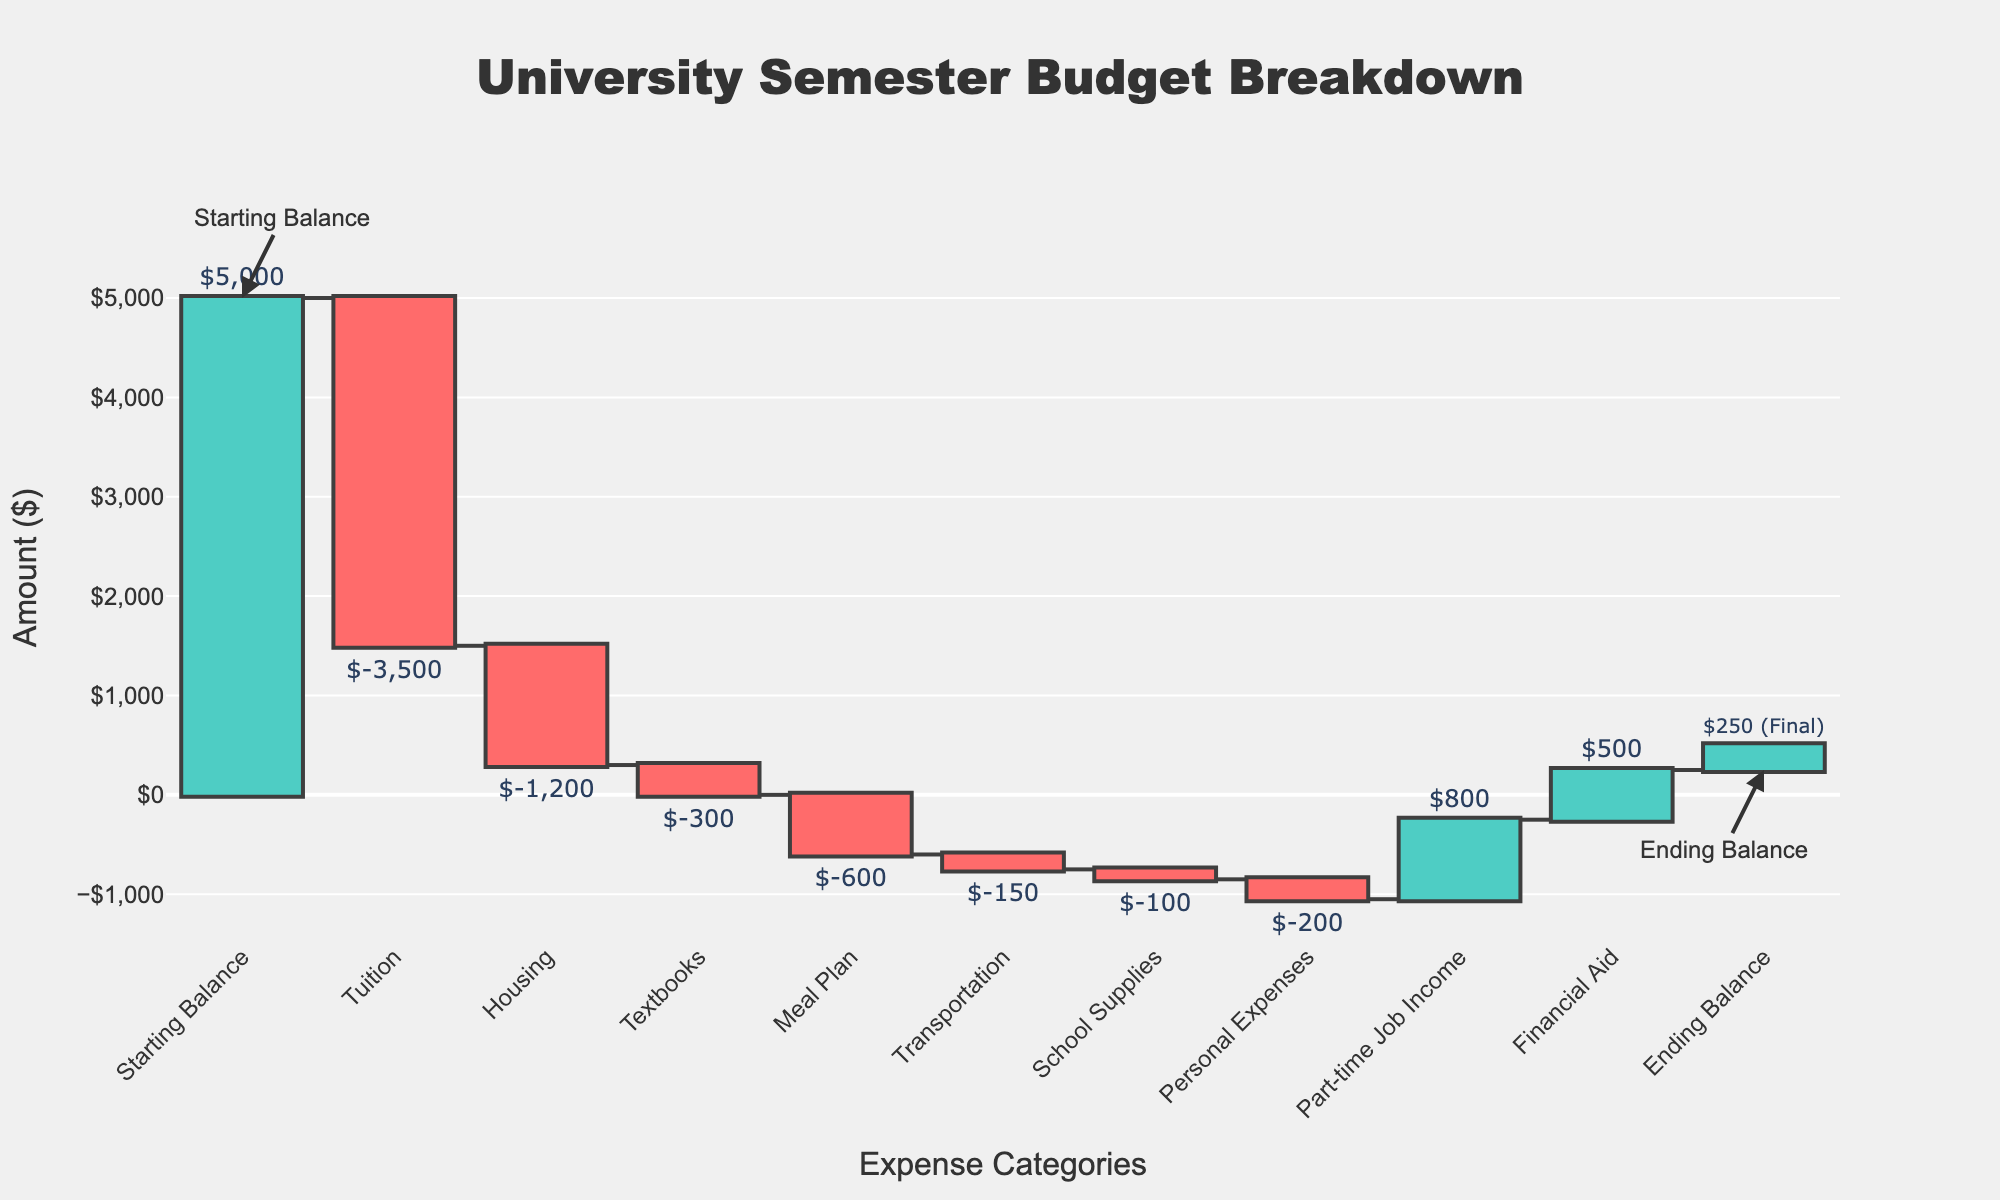What is the title of the Waterfall Chart? The title is displayed at the top of the figure and provides an overall description of the chart.
Answer: University Semester Budget Breakdown What is the starting balance? The starting balance is marked at the beginning of the Waterfall Chart and annotated as "Starting Balance."
Answer: $5,000 How does the tuition expense compare to the housing expense? The waterfall shows bars for both tuition and housing. The tuition expense bar is much larger, indicating it is the larger expense.
Answer: Tuition is higher What is the ending balance? The ending balance is annotated at the end of the chart and is marked as "Ending Balance."
Answer: $250 Which category has the largest negative impact on the budget? The longest negative bar on the chart indicates the largest expense, which corresponds to the category Tuition.
Answer: Tuition How much financial aid is received? The financial aid is represented by a positive bar labeled as Financial Aid.
Answer: $500 What is the net change in balance after including the part-time job income and financial aid? Start by identifying both positive bars for part-time job income ($800) and financial aid ($500). Add these two amounts together to find the net increase.
Answer: $1,300 What is the total amount spent on Textbooks, Meal Plan, and Personal Expenses? Identify the negative bars for Textbooks (-$300), Meal Plan (-$600), and Personal Expenses (-$200). Add these expenses together: -$300 + -$600 + -$200 = -$1,100.
Answer: $1,100 Which two categories together have a total expense of more than $3,000? Identify the expenses for each category. Tuition (-$3,500) alone already surpasses $3,000, so only tuition and any other expense (like Housing, -$1,200) would suffice. Tuition alone meets this.
Answer: Tuition alone What is the difference between the total amount spent on Housing and School Supplies? Identify the expenses: Housing (-$1,200) and School Supplies (-$100). Subtract the smaller from the larger: -$1,200 - -$100 = -$1,100.
Answer: $1,100 